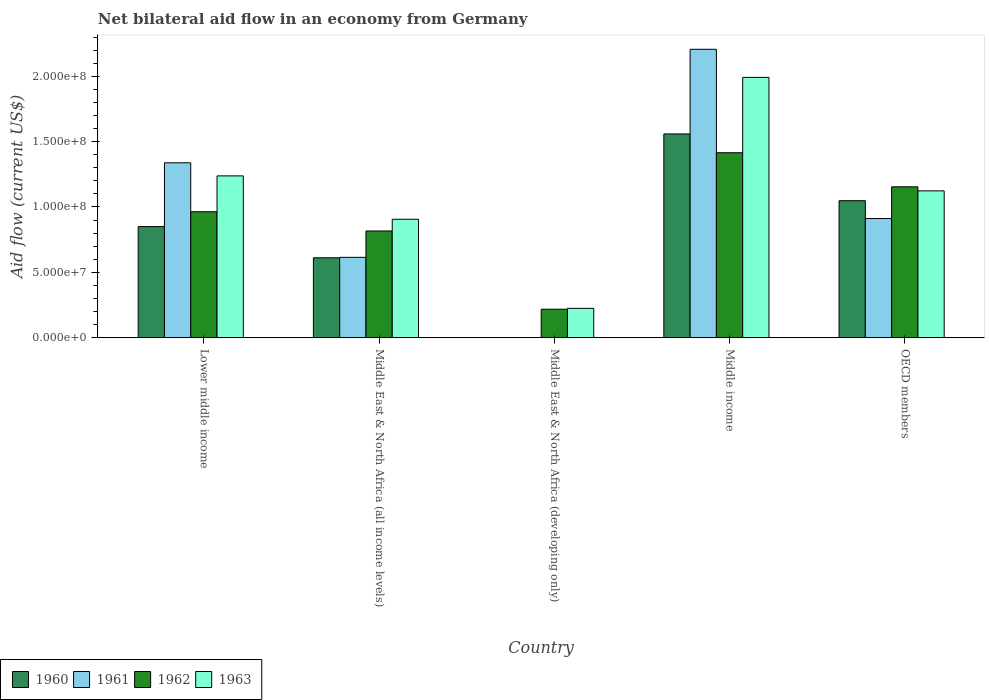How many different coloured bars are there?
Your response must be concise. 4. How many groups of bars are there?
Provide a short and direct response. 5. Are the number of bars on each tick of the X-axis equal?
Give a very brief answer. No. How many bars are there on the 5th tick from the left?
Your answer should be very brief. 4. How many bars are there on the 3rd tick from the right?
Provide a succinct answer. 2. What is the label of the 3rd group of bars from the left?
Provide a short and direct response. Middle East & North Africa (developing only). In how many cases, is the number of bars for a given country not equal to the number of legend labels?
Provide a short and direct response. 1. What is the net bilateral aid flow in 1963 in OECD members?
Provide a succinct answer. 1.12e+08. Across all countries, what is the maximum net bilateral aid flow in 1961?
Offer a terse response. 2.21e+08. What is the total net bilateral aid flow in 1962 in the graph?
Your answer should be very brief. 4.57e+08. What is the difference between the net bilateral aid flow in 1960 in Middle East & North Africa (all income levels) and that in OECD members?
Your answer should be very brief. -4.37e+07. What is the difference between the net bilateral aid flow in 1960 in Middle income and the net bilateral aid flow in 1961 in Middle East & North Africa (developing only)?
Offer a very short reply. 1.56e+08. What is the average net bilateral aid flow in 1962 per country?
Make the answer very short. 9.13e+07. What is the difference between the net bilateral aid flow of/in 1960 and net bilateral aid flow of/in 1962 in Middle East & North Africa (all income levels)?
Make the answer very short. -2.05e+07. In how many countries, is the net bilateral aid flow in 1963 greater than 80000000 US$?
Make the answer very short. 4. What is the ratio of the net bilateral aid flow in 1962 in Lower middle income to that in OECD members?
Your answer should be compact. 0.83. Is the difference between the net bilateral aid flow in 1960 in Lower middle income and OECD members greater than the difference between the net bilateral aid flow in 1962 in Lower middle income and OECD members?
Provide a short and direct response. No. What is the difference between the highest and the second highest net bilateral aid flow in 1961?
Provide a succinct answer. 8.69e+07. What is the difference between the highest and the lowest net bilateral aid flow in 1963?
Offer a very short reply. 1.77e+08. Is the sum of the net bilateral aid flow in 1962 in Middle income and OECD members greater than the maximum net bilateral aid flow in 1961 across all countries?
Make the answer very short. Yes. Is it the case that in every country, the sum of the net bilateral aid flow in 1962 and net bilateral aid flow in 1960 is greater than the net bilateral aid flow in 1961?
Make the answer very short. Yes. How many bars are there?
Give a very brief answer. 18. Are all the bars in the graph horizontal?
Your response must be concise. No. Does the graph contain any zero values?
Provide a short and direct response. Yes. Does the graph contain grids?
Make the answer very short. No. How many legend labels are there?
Make the answer very short. 4. How are the legend labels stacked?
Your answer should be compact. Horizontal. What is the title of the graph?
Give a very brief answer. Net bilateral aid flow in an economy from Germany. What is the label or title of the Y-axis?
Your response must be concise. Aid flow (current US$). What is the Aid flow (current US$) of 1960 in Lower middle income?
Offer a very short reply. 8.50e+07. What is the Aid flow (current US$) in 1961 in Lower middle income?
Make the answer very short. 1.34e+08. What is the Aid flow (current US$) of 1962 in Lower middle income?
Ensure brevity in your answer.  9.64e+07. What is the Aid flow (current US$) in 1963 in Lower middle income?
Keep it short and to the point. 1.24e+08. What is the Aid flow (current US$) in 1960 in Middle East & North Africa (all income levels)?
Keep it short and to the point. 6.11e+07. What is the Aid flow (current US$) in 1961 in Middle East & North Africa (all income levels)?
Offer a very short reply. 6.15e+07. What is the Aid flow (current US$) of 1962 in Middle East & North Africa (all income levels)?
Your answer should be compact. 8.16e+07. What is the Aid flow (current US$) of 1963 in Middle East & North Africa (all income levels)?
Provide a short and direct response. 9.06e+07. What is the Aid flow (current US$) in 1960 in Middle East & North Africa (developing only)?
Provide a succinct answer. 0. What is the Aid flow (current US$) in 1961 in Middle East & North Africa (developing only)?
Give a very brief answer. 0. What is the Aid flow (current US$) in 1962 in Middle East & North Africa (developing only)?
Give a very brief answer. 2.18e+07. What is the Aid flow (current US$) in 1963 in Middle East & North Africa (developing only)?
Give a very brief answer. 2.24e+07. What is the Aid flow (current US$) of 1960 in Middle income?
Your response must be concise. 1.56e+08. What is the Aid flow (current US$) of 1961 in Middle income?
Provide a succinct answer. 2.21e+08. What is the Aid flow (current US$) in 1962 in Middle income?
Your response must be concise. 1.42e+08. What is the Aid flow (current US$) in 1963 in Middle income?
Ensure brevity in your answer.  1.99e+08. What is the Aid flow (current US$) in 1960 in OECD members?
Your answer should be very brief. 1.05e+08. What is the Aid flow (current US$) in 1961 in OECD members?
Give a very brief answer. 9.12e+07. What is the Aid flow (current US$) of 1962 in OECD members?
Ensure brevity in your answer.  1.15e+08. What is the Aid flow (current US$) in 1963 in OECD members?
Make the answer very short. 1.12e+08. Across all countries, what is the maximum Aid flow (current US$) in 1960?
Give a very brief answer. 1.56e+08. Across all countries, what is the maximum Aid flow (current US$) in 1961?
Offer a very short reply. 2.21e+08. Across all countries, what is the maximum Aid flow (current US$) of 1962?
Your response must be concise. 1.42e+08. Across all countries, what is the maximum Aid flow (current US$) of 1963?
Offer a terse response. 1.99e+08. Across all countries, what is the minimum Aid flow (current US$) in 1960?
Provide a succinct answer. 0. Across all countries, what is the minimum Aid flow (current US$) in 1961?
Provide a short and direct response. 0. Across all countries, what is the minimum Aid flow (current US$) in 1962?
Offer a terse response. 2.18e+07. Across all countries, what is the minimum Aid flow (current US$) in 1963?
Your answer should be compact. 2.24e+07. What is the total Aid flow (current US$) of 1960 in the graph?
Provide a succinct answer. 4.07e+08. What is the total Aid flow (current US$) in 1961 in the graph?
Provide a succinct answer. 5.07e+08. What is the total Aid flow (current US$) of 1962 in the graph?
Provide a short and direct response. 4.57e+08. What is the total Aid flow (current US$) of 1963 in the graph?
Ensure brevity in your answer.  5.48e+08. What is the difference between the Aid flow (current US$) of 1960 in Lower middle income and that in Middle East & North Africa (all income levels)?
Make the answer very short. 2.39e+07. What is the difference between the Aid flow (current US$) in 1961 in Lower middle income and that in Middle East & North Africa (all income levels)?
Provide a succinct answer. 7.24e+07. What is the difference between the Aid flow (current US$) of 1962 in Lower middle income and that in Middle East & North Africa (all income levels)?
Give a very brief answer. 1.47e+07. What is the difference between the Aid flow (current US$) in 1963 in Lower middle income and that in Middle East & North Africa (all income levels)?
Offer a terse response. 3.32e+07. What is the difference between the Aid flow (current US$) of 1962 in Lower middle income and that in Middle East & North Africa (developing only)?
Provide a short and direct response. 7.46e+07. What is the difference between the Aid flow (current US$) in 1963 in Lower middle income and that in Middle East & North Africa (developing only)?
Offer a very short reply. 1.01e+08. What is the difference between the Aid flow (current US$) of 1960 in Lower middle income and that in Middle income?
Ensure brevity in your answer.  -7.09e+07. What is the difference between the Aid flow (current US$) of 1961 in Lower middle income and that in Middle income?
Your response must be concise. -8.69e+07. What is the difference between the Aid flow (current US$) in 1962 in Lower middle income and that in Middle income?
Offer a very short reply. -4.52e+07. What is the difference between the Aid flow (current US$) in 1963 in Lower middle income and that in Middle income?
Provide a short and direct response. -7.54e+07. What is the difference between the Aid flow (current US$) in 1960 in Lower middle income and that in OECD members?
Your response must be concise. -1.98e+07. What is the difference between the Aid flow (current US$) of 1961 in Lower middle income and that in OECD members?
Your answer should be compact. 4.27e+07. What is the difference between the Aid flow (current US$) of 1962 in Lower middle income and that in OECD members?
Offer a very short reply. -1.91e+07. What is the difference between the Aid flow (current US$) of 1963 in Lower middle income and that in OECD members?
Keep it short and to the point. 1.14e+07. What is the difference between the Aid flow (current US$) of 1962 in Middle East & North Africa (all income levels) and that in Middle East & North Africa (developing only)?
Offer a very short reply. 5.99e+07. What is the difference between the Aid flow (current US$) of 1963 in Middle East & North Africa (all income levels) and that in Middle East & North Africa (developing only)?
Ensure brevity in your answer.  6.82e+07. What is the difference between the Aid flow (current US$) in 1960 in Middle East & North Africa (all income levels) and that in Middle income?
Your response must be concise. -9.48e+07. What is the difference between the Aid flow (current US$) of 1961 in Middle East & North Africa (all income levels) and that in Middle income?
Provide a short and direct response. -1.59e+08. What is the difference between the Aid flow (current US$) of 1962 in Middle East & North Africa (all income levels) and that in Middle income?
Your response must be concise. -5.99e+07. What is the difference between the Aid flow (current US$) of 1963 in Middle East & North Africa (all income levels) and that in Middle income?
Your answer should be very brief. -1.09e+08. What is the difference between the Aid flow (current US$) of 1960 in Middle East & North Africa (all income levels) and that in OECD members?
Your answer should be compact. -4.37e+07. What is the difference between the Aid flow (current US$) of 1961 in Middle East & North Africa (all income levels) and that in OECD members?
Your answer should be compact. -2.97e+07. What is the difference between the Aid flow (current US$) of 1962 in Middle East & North Africa (all income levels) and that in OECD members?
Make the answer very short. -3.38e+07. What is the difference between the Aid flow (current US$) of 1963 in Middle East & North Africa (all income levels) and that in OECD members?
Your answer should be compact. -2.17e+07. What is the difference between the Aid flow (current US$) of 1962 in Middle East & North Africa (developing only) and that in Middle income?
Offer a very short reply. -1.20e+08. What is the difference between the Aid flow (current US$) in 1963 in Middle East & North Africa (developing only) and that in Middle income?
Provide a succinct answer. -1.77e+08. What is the difference between the Aid flow (current US$) of 1962 in Middle East & North Africa (developing only) and that in OECD members?
Your answer should be very brief. -9.37e+07. What is the difference between the Aid flow (current US$) in 1963 in Middle East & North Africa (developing only) and that in OECD members?
Keep it short and to the point. -8.99e+07. What is the difference between the Aid flow (current US$) of 1960 in Middle income and that in OECD members?
Give a very brief answer. 5.11e+07. What is the difference between the Aid flow (current US$) in 1961 in Middle income and that in OECD members?
Your answer should be very brief. 1.30e+08. What is the difference between the Aid flow (current US$) of 1962 in Middle income and that in OECD members?
Your answer should be very brief. 2.61e+07. What is the difference between the Aid flow (current US$) of 1963 in Middle income and that in OECD members?
Your answer should be compact. 8.68e+07. What is the difference between the Aid flow (current US$) of 1960 in Lower middle income and the Aid flow (current US$) of 1961 in Middle East & North Africa (all income levels)?
Offer a very short reply. 2.36e+07. What is the difference between the Aid flow (current US$) in 1960 in Lower middle income and the Aid flow (current US$) in 1962 in Middle East & North Africa (all income levels)?
Offer a terse response. 3.38e+06. What is the difference between the Aid flow (current US$) of 1960 in Lower middle income and the Aid flow (current US$) of 1963 in Middle East & North Africa (all income levels)?
Keep it short and to the point. -5.59e+06. What is the difference between the Aid flow (current US$) of 1961 in Lower middle income and the Aid flow (current US$) of 1962 in Middle East & North Africa (all income levels)?
Your response must be concise. 5.22e+07. What is the difference between the Aid flow (current US$) of 1961 in Lower middle income and the Aid flow (current US$) of 1963 in Middle East & North Africa (all income levels)?
Offer a terse response. 4.32e+07. What is the difference between the Aid flow (current US$) of 1962 in Lower middle income and the Aid flow (current US$) of 1963 in Middle East & North Africa (all income levels)?
Your response must be concise. 5.75e+06. What is the difference between the Aid flow (current US$) in 1960 in Lower middle income and the Aid flow (current US$) in 1962 in Middle East & North Africa (developing only)?
Provide a succinct answer. 6.32e+07. What is the difference between the Aid flow (current US$) of 1960 in Lower middle income and the Aid flow (current US$) of 1963 in Middle East & North Africa (developing only)?
Give a very brief answer. 6.26e+07. What is the difference between the Aid flow (current US$) in 1961 in Lower middle income and the Aid flow (current US$) in 1962 in Middle East & North Africa (developing only)?
Your answer should be compact. 1.12e+08. What is the difference between the Aid flow (current US$) in 1961 in Lower middle income and the Aid flow (current US$) in 1963 in Middle East & North Africa (developing only)?
Keep it short and to the point. 1.11e+08. What is the difference between the Aid flow (current US$) in 1962 in Lower middle income and the Aid flow (current US$) in 1963 in Middle East & North Africa (developing only)?
Ensure brevity in your answer.  7.39e+07. What is the difference between the Aid flow (current US$) in 1960 in Lower middle income and the Aid flow (current US$) in 1961 in Middle income?
Make the answer very short. -1.36e+08. What is the difference between the Aid flow (current US$) in 1960 in Lower middle income and the Aid flow (current US$) in 1962 in Middle income?
Your answer should be very brief. -5.65e+07. What is the difference between the Aid flow (current US$) of 1960 in Lower middle income and the Aid flow (current US$) of 1963 in Middle income?
Ensure brevity in your answer.  -1.14e+08. What is the difference between the Aid flow (current US$) in 1961 in Lower middle income and the Aid flow (current US$) in 1962 in Middle income?
Make the answer very short. -7.71e+06. What is the difference between the Aid flow (current US$) of 1961 in Lower middle income and the Aid flow (current US$) of 1963 in Middle income?
Give a very brief answer. -6.54e+07. What is the difference between the Aid flow (current US$) of 1962 in Lower middle income and the Aid flow (current US$) of 1963 in Middle income?
Offer a very short reply. -1.03e+08. What is the difference between the Aid flow (current US$) in 1960 in Lower middle income and the Aid flow (current US$) in 1961 in OECD members?
Make the answer very short. -6.14e+06. What is the difference between the Aid flow (current US$) in 1960 in Lower middle income and the Aid flow (current US$) in 1962 in OECD members?
Make the answer very short. -3.04e+07. What is the difference between the Aid flow (current US$) in 1960 in Lower middle income and the Aid flow (current US$) in 1963 in OECD members?
Your response must be concise. -2.73e+07. What is the difference between the Aid flow (current US$) of 1961 in Lower middle income and the Aid flow (current US$) of 1962 in OECD members?
Keep it short and to the point. 1.84e+07. What is the difference between the Aid flow (current US$) of 1961 in Lower middle income and the Aid flow (current US$) of 1963 in OECD members?
Offer a terse response. 2.15e+07. What is the difference between the Aid flow (current US$) in 1962 in Lower middle income and the Aid flow (current US$) in 1963 in OECD members?
Offer a very short reply. -1.60e+07. What is the difference between the Aid flow (current US$) of 1960 in Middle East & North Africa (all income levels) and the Aid flow (current US$) of 1962 in Middle East & North Africa (developing only)?
Your answer should be very brief. 3.94e+07. What is the difference between the Aid flow (current US$) of 1960 in Middle East & North Africa (all income levels) and the Aid flow (current US$) of 1963 in Middle East & North Africa (developing only)?
Provide a succinct answer. 3.87e+07. What is the difference between the Aid flow (current US$) of 1961 in Middle East & North Africa (all income levels) and the Aid flow (current US$) of 1962 in Middle East & North Africa (developing only)?
Make the answer very short. 3.97e+07. What is the difference between the Aid flow (current US$) in 1961 in Middle East & North Africa (all income levels) and the Aid flow (current US$) in 1963 in Middle East & North Africa (developing only)?
Provide a short and direct response. 3.90e+07. What is the difference between the Aid flow (current US$) of 1962 in Middle East & North Africa (all income levels) and the Aid flow (current US$) of 1963 in Middle East & North Africa (developing only)?
Offer a very short reply. 5.92e+07. What is the difference between the Aid flow (current US$) of 1960 in Middle East & North Africa (all income levels) and the Aid flow (current US$) of 1961 in Middle income?
Your answer should be compact. -1.60e+08. What is the difference between the Aid flow (current US$) of 1960 in Middle East & North Africa (all income levels) and the Aid flow (current US$) of 1962 in Middle income?
Offer a terse response. -8.04e+07. What is the difference between the Aid flow (current US$) of 1960 in Middle East & North Africa (all income levels) and the Aid flow (current US$) of 1963 in Middle income?
Provide a succinct answer. -1.38e+08. What is the difference between the Aid flow (current US$) in 1961 in Middle East & North Africa (all income levels) and the Aid flow (current US$) in 1962 in Middle income?
Ensure brevity in your answer.  -8.01e+07. What is the difference between the Aid flow (current US$) of 1961 in Middle East & North Africa (all income levels) and the Aid flow (current US$) of 1963 in Middle income?
Ensure brevity in your answer.  -1.38e+08. What is the difference between the Aid flow (current US$) of 1962 in Middle East & North Africa (all income levels) and the Aid flow (current US$) of 1963 in Middle income?
Your answer should be compact. -1.18e+08. What is the difference between the Aid flow (current US$) in 1960 in Middle East & North Africa (all income levels) and the Aid flow (current US$) in 1961 in OECD members?
Ensure brevity in your answer.  -3.00e+07. What is the difference between the Aid flow (current US$) of 1960 in Middle East & North Africa (all income levels) and the Aid flow (current US$) of 1962 in OECD members?
Ensure brevity in your answer.  -5.43e+07. What is the difference between the Aid flow (current US$) of 1960 in Middle East & North Africa (all income levels) and the Aid flow (current US$) of 1963 in OECD members?
Make the answer very short. -5.12e+07. What is the difference between the Aid flow (current US$) in 1961 in Middle East & North Africa (all income levels) and the Aid flow (current US$) in 1962 in OECD members?
Offer a very short reply. -5.40e+07. What is the difference between the Aid flow (current US$) in 1961 in Middle East & North Africa (all income levels) and the Aid flow (current US$) in 1963 in OECD members?
Ensure brevity in your answer.  -5.09e+07. What is the difference between the Aid flow (current US$) in 1962 in Middle East & North Africa (all income levels) and the Aid flow (current US$) in 1963 in OECD members?
Your response must be concise. -3.07e+07. What is the difference between the Aid flow (current US$) in 1962 in Middle East & North Africa (developing only) and the Aid flow (current US$) in 1963 in Middle income?
Your answer should be compact. -1.77e+08. What is the difference between the Aid flow (current US$) of 1962 in Middle East & North Africa (developing only) and the Aid flow (current US$) of 1963 in OECD members?
Your answer should be very brief. -9.06e+07. What is the difference between the Aid flow (current US$) in 1960 in Middle income and the Aid flow (current US$) in 1961 in OECD members?
Your answer should be compact. 6.48e+07. What is the difference between the Aid flow (current US$) of 1960 in Middle income and the Aid flow (current US$) of 1962 in OECD members?
Your answer should be compact. 4.05e+07. What is the difference between the Aid flow (current US$) in 1960 in Middle income and the Aid flow (current US$) in 1963 in OECD members?
Offer a very short reply. 4.36e+07. What is the difference between the Aid flow (current US$) of 1961 in Middle income and the Aid flow (current US$) of 1962 in OECD members?
Offer a terse response. 1.05e+08. What is the difference between the Aid flow (current US$) of 1961 in Middle income and the Aid flow (current US$) of 1963 in OECD members?
Keep it short and to the point. 1.08e+08. What is the difference between the Aid flow (current US$) in 1962 in Middle income and the Aid flow (current US$) in 1963 in OECD members?
Your answer should be very brief. 2.92e+07. What is the average Aid flow (current US$) in 1960 per country?
Your answer should be very brief. 8.14e+07. What is the average Aid flow (current US$) in 1961 per country?
Offer a very short reply. 1.01e+08. What is the average Aid flow (current US$) in 1962 per country?
Ensure brevity in your answer.  9.13e+07. What is the average Aid flow (current US$) in 1963 per country?
Your response must be concise. 1.10e+08. What is the difference between the Aid flow (current US$) of 1960 and Aid flow (current US$) of 1961 in Lower middle income?
Give a very brief answer. -4.88e+07. What is the difference between the Aid flow (current US$) in 1960 and Aid flow (current US$) in 1962 in Lower middle income?
Offer a very short reply. -1.13e+07. What is the difference between the Aid flow (current US$) in 1960 and Aid flow (current US$) in 1963 in Lower middle income?
Make the answer very short. -3.88e+07. What is the difference between the Aid flow (current US$) in 1961 and Aid flow (current US$) in 1962 in Lower middle income?
Provide a succinct answer. 3.75e+07. What is the difference between the Aid flow (current US$) in 1961 and Aid flow (current US$) in 1963 in Lower middle income?
Provide a succinct answer. 1.00e+07. What is the difference between the Aid flow (current US$) of 1962 and Aid flow (current US$) of 1963 in Lower middle income?
Your response must be concise. -2.74e+07. What is the difference between the Aid flow (current US$) of 1960 and Aid flow (current US$) of 1961 in Middle East & North Africa (all income levels)?
Your response must be concise. -3.30e+05. What is the difference between the Aid flow (current US$) of 1960 and Aid flow (current US$) of 1962 in Middle East & North Africa (all income levels)?
Ensure brevity in your answer.  -2.05e+07. What is the difference between the Aid flow (current US$) of 1960 and Aid flow (current US$) of 1963 in Middle East & North Africa (all income levels)?
Give a very brief answer. -2.95e+07. What is the difference between the Aid flow (current US$) of 1961 and Aid flow (current US$) of 1962 in Middle East & North Africa (all income levels)?
Provide a succinct answer. -2.02e+07. What is the difference between the Aid flow (current US$) of 1961 and Aid flow (current US$) of 1963 in Middle East & North Africa (all income levels)?
Your answer should be compact. -2.91e+07. What is the difference between the Aid flow (current US$) in 1962 and Aid flow (current US$) in 1963 in Middle East & North Africa (all income levels)?
Your answer should be compact. -8.97e+06. What is the difference between the Aid flow (current US$) in 1962 and Aid flow (current US$) in 1963 in Middle East & North Africa (developing only)?
Provide a succinct answer. -6.70e+05. What is the difference between the Aid flow (current US$) in 1960 and Aid flow (current US$) in 1961 in Middle income?
Your answer should be very brief. -6.48e+07. What is the difference between the Aid flow (current US$) in 1960 and Aid flow (current US$) in 1962 in Middle income?
Keep it short and to the point. 1.44e+07. What is the difference between the Aid flow (current US$) of 1960 and Aid flow (current US$) of 1963 in Middle income?
Offer a very short reply. -4.33e+07. What is the difference between the Aid flow (current US$) in 1961 and Aid flow (current US$) in 1962 in Middle income?
Your response must be concise. 7.92e+07. What is the difference between the Aid flow (current US$) in 1961 and Aid flow (current US$) in 1963 in Middle income?
Provide a succinct answer. 2.15e+07. What is the difference between the Aid flow (current US$) of 1962 and Aid flow (current US$) of 1963 in Middle income?
Give a very brief answer. -5.76e+07. What is the difference between the Aid flow (current US$) of 1960 and Aid flow (current US$) of 1961 in OECD members?
Ensure brevity in your answer.  1.36e+07. What is the difference between the Aid flow (current US$) of 1960 and Aid flow (current US$) of 1962 in OECD members?
Keep it short and to the point. -1.06e+07. What is the difference between the Aid flow (current US$) of 1960 and Aid flow (current US$) of 1963 in OECD members?
Your response must be concise. -7.55e+06. What is the difference between the Aid flow (current US$) of 1961 and Aid flow (current US$) of 1962 in OECD members?
Your answer should be very brief. -2.43e+07. What is the difference between the Aid flow (current US$) of 1961 and Aid flow (current US$) of 1963 in OECD members?
Offer a terse response. -2.12e+07. What is the difference between the Aid flow (current US$) in 1962 and Aid flow (current US$) in 1963 in OECD members?
Your answer should be compact. 3.09e+06. What is the ratio of the Aid flow (current US$) of 1960 in Lower middle income to that in Middle East & North Africa (all income levels)?
Your answer should be very brief. 1.39. What is the ratio of the Aid flow (current US$) in 1961 in Lower middle income to that in Middle East & North Africa (all income levels)?
Make the answer very short. 2.18. What is the ratio of the Aid flow (current US$) of 1962 in Lower middle income to that in Middle East & North Africa (all income levels)?
Provide a succinct answer. 1.18. What is the ratio of the Aid flow (current US$) in 1963 in Lower middle income to that in Middle East & North Africa (all income levels)?
Your response must be concise. 1.37. What is the ratio of the Aid flow (current US$) of 1962 in Lower middle income to that in Middle East & North Africa (developing only)?
Make the answer very short. 4.43. What is the ratio of the Aid flow (current US$) of 1963 in Lower middle income to that in Middle East & North Africa (developing only)?
Ensure brevity in your answer.  5.52. What is the ratio of the Aid flow (current US$) of 1960 in Lower middle income to that in Middle income?
Give a very brief answer. 0.55. What is the ratio of the Aid flow (current US$) of 1961 in Lower middle income to that in Middle income?
Your answer should be very brief. 0.61. What is the ratio of the Aid flow (current US$) of 1962 in Lower middle income to that in Middle income?
Your answer should be very brief. 0.68. What is the ratio of the Aid flow (current US$) of 1963 in Lower middle income to that in Middle income?
Your answer should be very brief. 0.62. What is the ratio of the Aid flow (current US$) of 1960 in Lower middle income to that in OECD members?
Offer a terse response. 0.81. What is the ratio of the Aid flow (current US$) of 1961 in Lower middle income to that in OECD members?
Provide a short and direct response. 1.47. What is the ratio of the Aid flow (current US$) in 1962 in Lower middle income to that in OECD members?
Make the answer very short. 0.83. What is the ratio of the Aid flow (current US$) in 1963 in Lower middle income to that in OECD members?
Give a very brief answer. 1.1. What is the ratio of the Aid flow (current US$) in 1962 in Middle East & North Africa (all income levels) to that in Middle East & North Africa (developing only)?
Provide a succinct answer. 3.75. What is the ratio of the Aid flow (current US$) in 1963 in Middle East & North Africa (all income levels) to that in Middle East & North Africa (developing only)?
Provide a succinct answer. 4.04. What is the ratio of the Aid flow (current US$) of 1960 in Middle East & North Africa (all income levels) to that in Middle income?
Ensure brevity in your answer.  0.39. What is the ratio of the Aid flow (current US$) of 1961 in Middle East & North Africa (all income levels) to that in Middle income?
Give a very brief answer. 0.28. What is the ratio of the Aid flow (current US$) in 1962 in Middle East & North Africa (all income levels) to that in Middle income?
Make the answer very short. 0.58. What is the ratio of the Aid flow (current US$) in 1963 in Middle East & North Africa (all income levels) to that in Middle income?
Give a very brief answer. 0.45. What is the ratio of the Aid flow (current US$) of 1960 in Middle East & North Africa (all income levels) to that in OECD members?
Ensure brevity in your answer.  0.58. What is the ratio of the Aid flow (current US$) of 1961 in Middle East & North Africa (all income levels) to that in OECD members?
Give a very brief answer. 0.67. What is the ratio of the Aid flow (current US$) in 1962 in Middle East & North Africa (all income levels) to that in OECD members?
Give a very brief answer. 0.71. What is the ratio of the Aid flow (current US$) in 1963 in Middle East & North Africa (all income levels) to that in OECD members?
Make the answer very short. 0.81. What is the ratio of the Aid flow (current US$) in 1962 in Middle East & North Africa (developing only) to that in Middle income?
Give a very brief answer. 0.15. What is the ratio of the Aid flow (current US$) of 1963 in Middle East & North Africa (developing only) to that in Middle income?
Ensure brevity in your answer.  0.11. What is the ratio of the Aid flow (current US$) in 1962 in Middle East & North Africa (developing only) to that in OECD members?
Your response must be concise. 0.19. What is the ratio of the Aid flow (current US$) of 1963 in Middle East & North Africa (developing only) to that in OECD members?
Give a very brief answer. 0.2. What is the ratio of the Aid flow (current US$) of 1960 in Middle income to that in OECD members?
Give a very brief answer. 1.49. What is the ratio of the Aid flow (current US$) of 1961 in Middle income to that in OECD members?
Your answer should be compact. 2.42. What is the ratio of the Aid flow (current US$) in 1962 in Middle income to that in OECD members?
Give a very brief answer. 1.23. What is the ratio of the Aid flow (current US$) of 1963 in Middle income to that in OECD members?
Your response must be concise. 1.77. What is the difference between the highest and the second highest Aid flow (current US$) of 1960?
Offer a very short reply. 5.11e+07. What is the difference between the highest and the second highest Aid flow (current US$) of 1961?
Keep it short and to the point. 8.69e+07. What is the difference between the highest and the second highest Aid flow (current US$) of 1962?
Your answer should be very brief. 2.61e+07. What is the difference between the highest and the second highest Aid flow (current US$) of 1963?
Provide a short and direct response. 7.54e+07. What is the difference between the highest and the lowest Aid flow (current US$) of 1960?
Give a very brief answer. 1.56e+08. What is the difference between the highest and the lowest Aid flow (current US$) of 1961?
Provide a succinct answer. 2.21e+08. What is the difference between the highest and the lowest Aid flow (current US$) in 1962?
Give a very brief answer. 1.20e+08. What is the difference between the highest and the lowest Aid flow (current US$) of 1963?
Provide a succinct answer. 1.77e+08. 